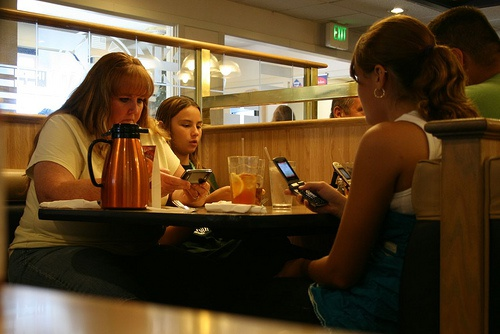Describe the objects in this image and their specific colors. I can see people in black, maroon, and olive tones, people in black, maroon, brown, and olive tones, dining table in black, lavender, olive, and tan tones, dining table in black, olive, maroon, and tan tones, and people in black, olive, and maroon tones in this image. 